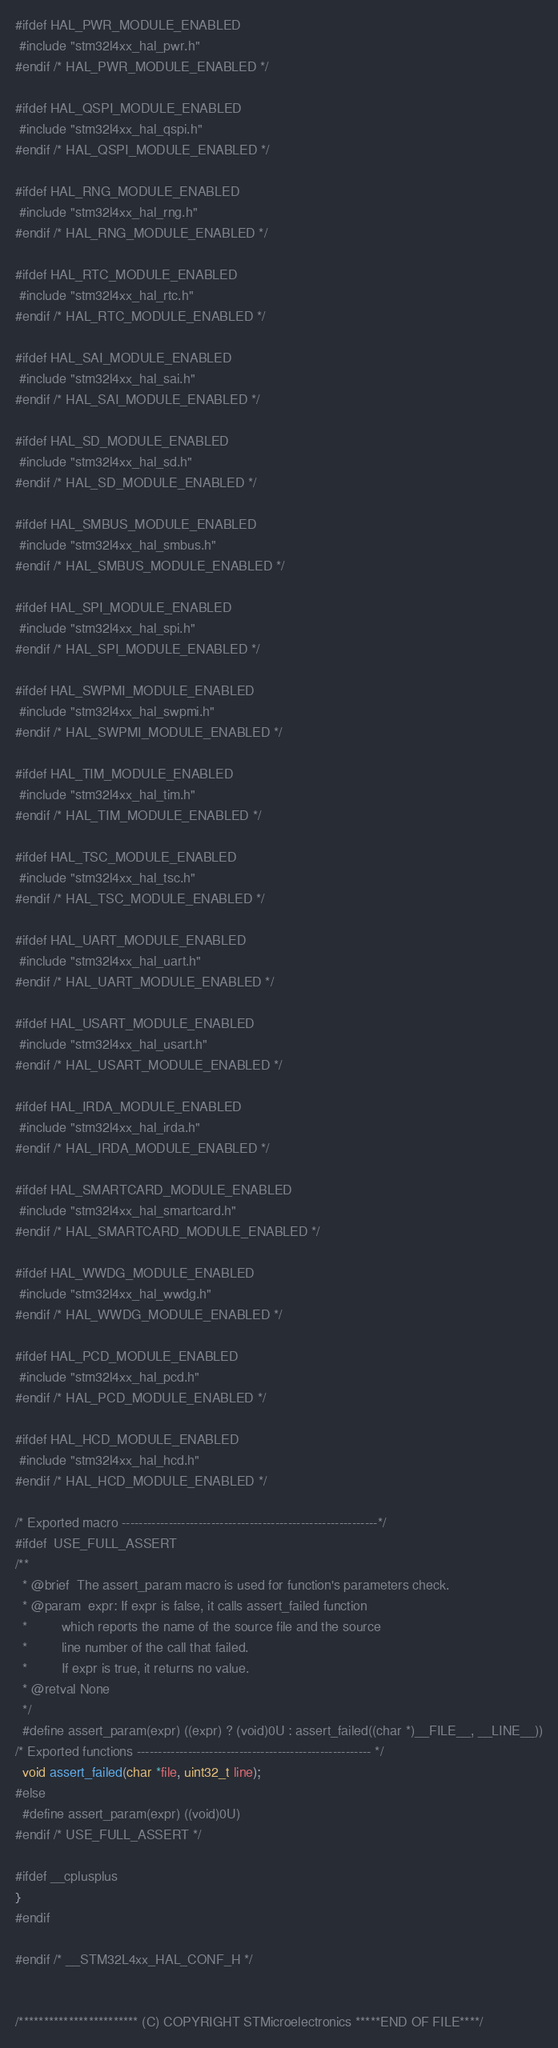<code> <loc_0><loc_0><loc_500><loc_500><_C_>
#ifdef HAL_PWR_MODULE_ENABLED
 #include "stm32l4xx_hal_pwr.h"
#endif /* HAL_PWR_MODULE_ENABLED */

#ifdef HAL_QSPI_MODULE_ENABLED
 #include "stm32l4xx_hal_qspi.h"
#endif /* HAL_QSPI_MODULE_ENABLED */

#ifdef HAL_RNG_MODULE_ENABLED
 #include "stm32l4xx_hal_rng.h"
#endif /* HAL_RNG_MODULE_ENABLED */

#ifdef HAL_RTC_MODULE_ENABLED
 #include "stm32l4xx_hal_rtc.h"
#endif /* HAL_RTC_MODULE_ENABLED */

#ifdef HAL_SAI_MODULE_ENABLED
 #include "stm32l4xx_hal_sai.h"
#endif /* HAL_SAI_MODULE_ENABLED */

#ifdef HAL_SD_MODULE_ENABLED
 #include "stm32l4xx_hal_sd.h"
#endif /* HAL_SD_MODULE_ENABLED */

#ifdef HAL_SMBUS_MODULE_ENABLED
 #include "stm32l4xx_hal_smbus.h"
#endif /* HAL_SMBUS_MODULE_ENABLED */

#ifdef HAL_SPI_MODULE_ENABLED
 #include "stm32l4xx_hal_spi.h"
#endif /* HAL_SPI_MODULE_ENABLED */

#ifdef HAL_SWPMI_MODULE_ENABLED
 #include "stm32l4xx_hal_swpmi.h"
#endif /* HAL_SWPMI_MODULE_ENABLED */

#ifdef HAL_TIM_MODULE_ENABLED
 #include "stm32l4xx_hal_tim.h"
#endif /* HAL_TIM_MODULE_ENABLED */

#ifdef HAL_TSC_MODULE_ENABLED
 #include "stm32l4xx_hal_tsc.h"
#endif /* HAL_TSC_MODULE_ENABLED */

#ifdef HAL_UART_MODULE_ENABLED
 #include "stm32l4xx_hal_uart.h"
#endif /* HAL_UART_MODULE_ENABLED */

#ifdef HAL_USART_MODULE_ENABLED
 #include "stm32l4xx_hal_usart.h"
#endif /* HAL_USART_MODULE_ENABLED */

#ifdef HAL_IRDA_MODULE_ENABLED
 #include "stm32l4xx_hal_irda.h"
#endif /* HAL_IRDA_MODULE_ENABLED */

#ifdef HAL_SMARTCARD_MODULE_ENABLED
 #include "stm32l4xx_hal_smartcard.h"
#endif /* HAL_SMARTCARD_MODULE_ENABLED */

#ifdef HAL_WWDG_MODULE_ENABLED
 #include "stm32l4xx_hal_wwdg.h"
#endif /* HAL_WWDG_MODULE_ENABLED */

#ifdef HAL_PCD_MODULE_ENABLED
 #include "stm32l4xx_hal_pcd.h"
#endif /* HAL_PCD_MODULE_ENABLED */

#ifdef HAL_HCD_MODULE_ENABLED
 #include "stm32l4xx_hal_hcd.h"
#endif /* HAL_HCD_MODULE_ENABLED */

/* Exported macro ------------------------------------------------------------*/
#ifdef  USE_FULL_ASSERT
/**
  * @brief  The assert_param macro is used for function's parameters check.
  * @param  expr: If expr is false, it calls assert_failed function
  *         which reports the name of the source file and the source
  *         line number of the call that failed.
  *         If expr is true, it returns no value.
  * @retval None
  */
  #define assert_param(expr) ((expr) ? (void)0U : assert_failed((char *)__FILE__, __LINE__))
/* Exported functions ------------------------------------------------------- */
  void assert_failed(char *file, uint32_t line);
#else
  #define assert_param(expr) ((void)0U)
#endif /* USE_FULL_ASSERT */

#ifdef __cplusplus
}
#endif

#endif /* __STM32L4xx_HAL_CONF_H */


/************************ (C) COPYRIGHT STMicroelectronics *****END OF FILE****/
</code> 